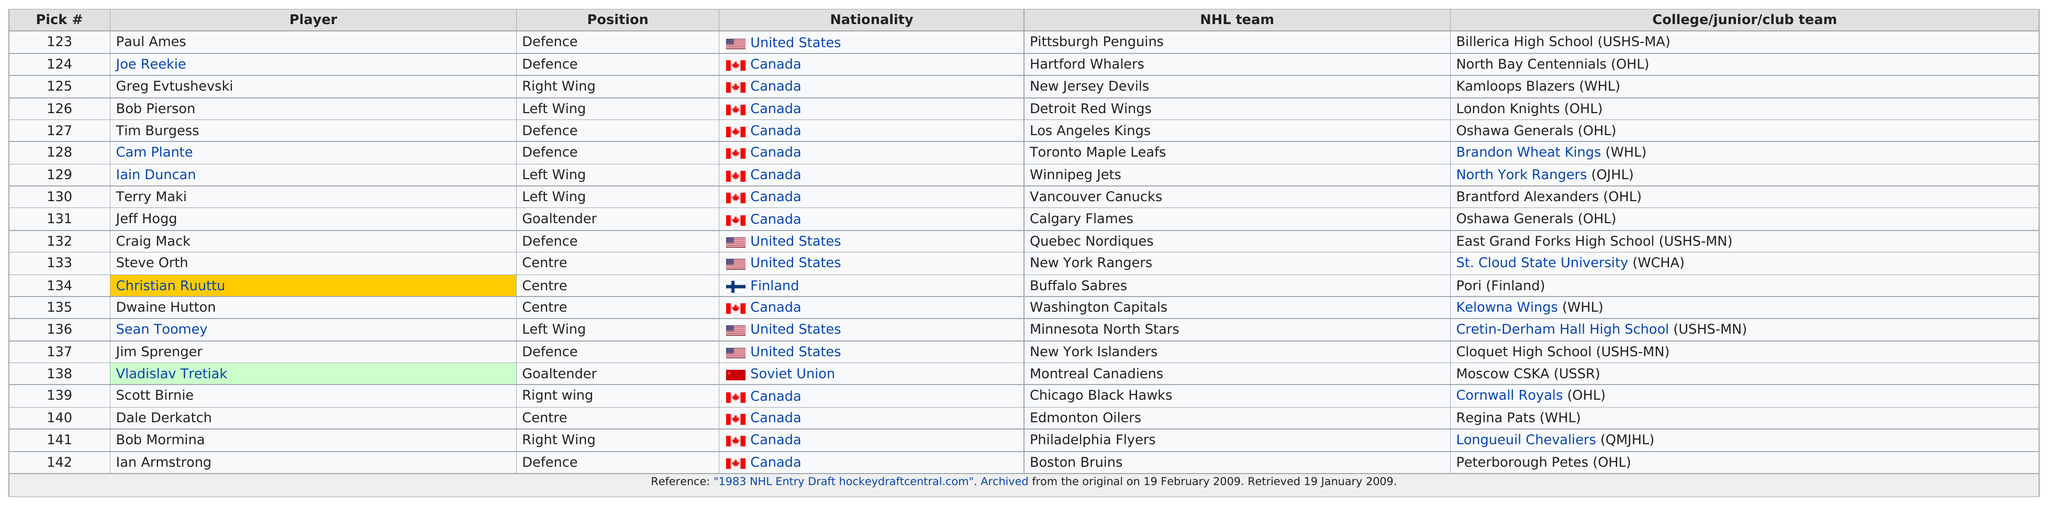Give some essential details in this illustration. The Boston Bruins are the team that is in last place on the table. Scott Birnie and Bob Mormina are both Canadian. The Boston Bruins had the last pick in the National Hockey League. Bob Pierson was drafted before Tim Burgess, who was drafted after Bob Pierson. After Paul Ames was selected for defense, the next United States defense pick was named Craig Mack. 